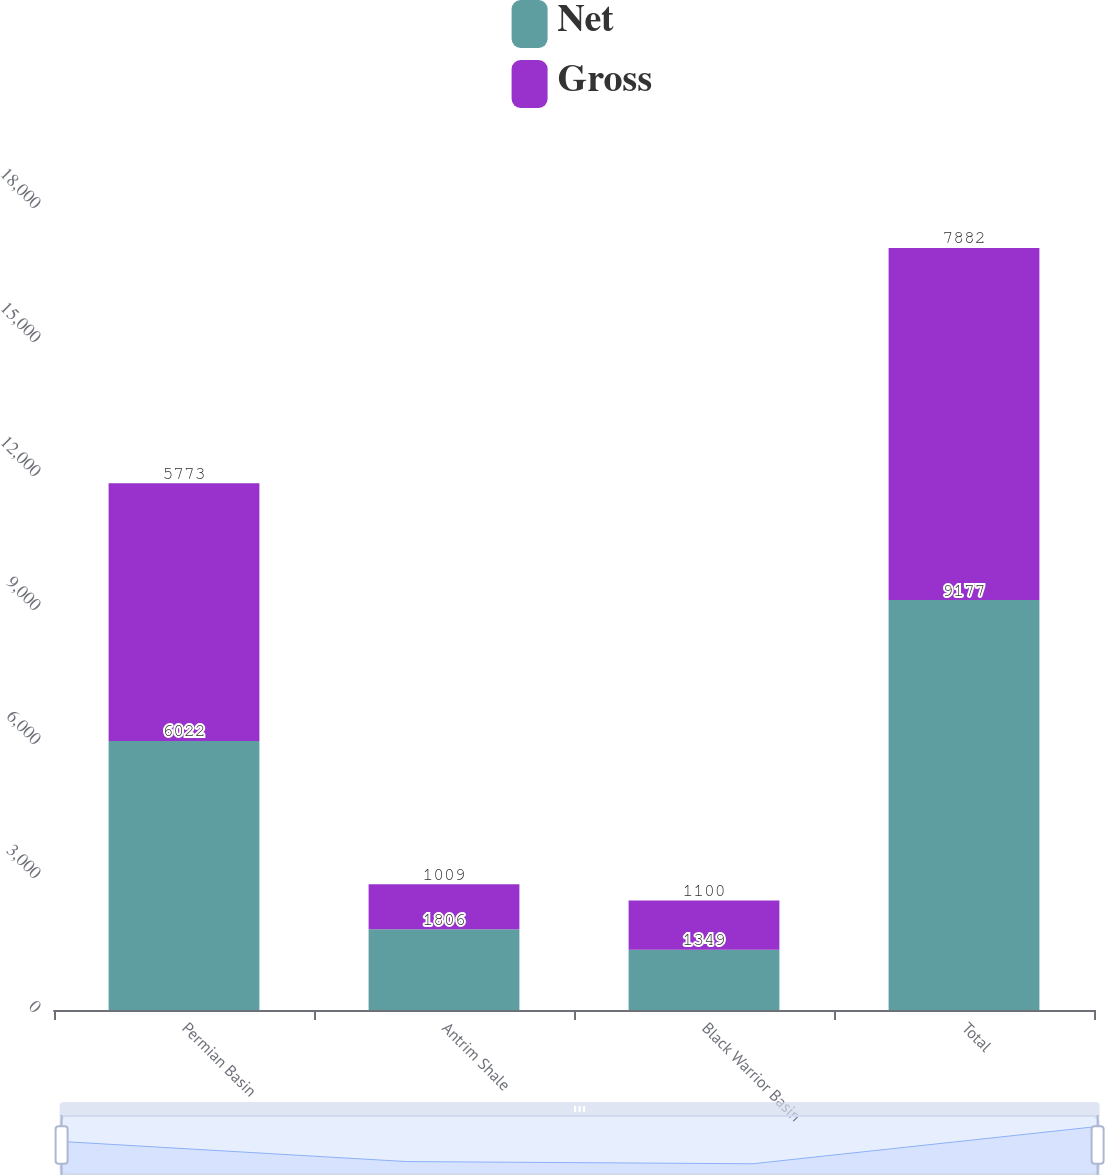Convert chart. <chart><loc_0><loc_0><loc_500><loc_500><stacked_bar_chart><ecel><fcel>Permian Basin<fcel>Antrim Shale<fcel>Black Warrior Basin<fcel>Total<nl><fcel>Net<fcel>6022<fcel>1806<fcel>1349<fcel>9177<nl><fcel>Gross<fcel>5773<fcel>1009<fcel>1100<fcel>7882<nl></chart> 